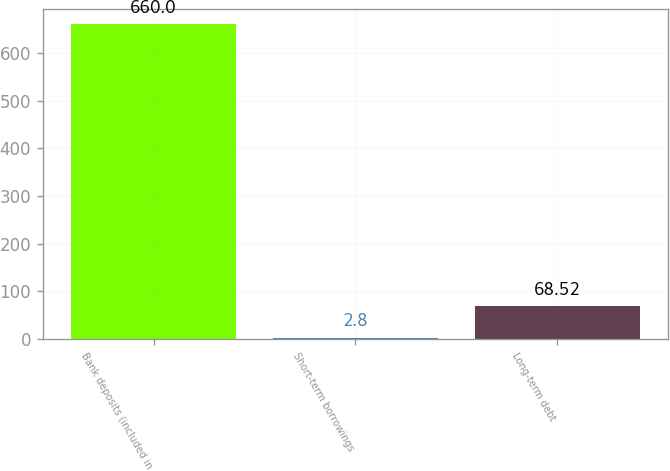Convert chart. <chart><loc_0><loc_0><loc_500><loc_500><bar_chart><fcel>Bank deposits (included in<fcel>Short-term borrowings<fcel>Long-term debt<nl><fcel>660<fcel>2.8<fcel>68.52<nl></chart> 